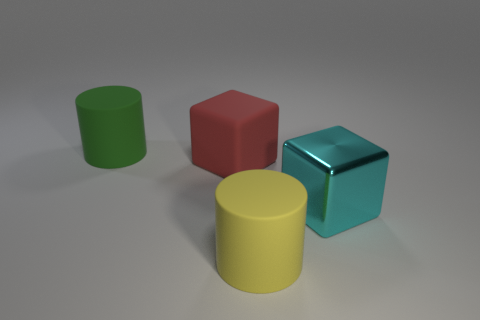Is there anything else that has the same material as the large cyan object?
Your response must be concise. No. What number of objects are blocks behind the cyan metal block or cubes behind the big metallic cube?
Offer a terse response. 1. There is a cylinder to the left of the red matte thing; is it the same size as the big cyan metal object?
Give a very brief answer. Yes. What is the size of the rubber thing that is the same shape as the shiny object?
Your answer should be compact. Large. There is a yellow cylinder that is the same size as the cyan block; what material is it?
Provide a succinct answer. Rubber. There is another thing that is the same shape as the big metal object; what material is it?
Provide a short and direct response. Rubber. What number of other objects are the same size as the cyan thing?
Make the answer very short. 3. What shape is the big red matte object?
Make the answer very short. Cube. There is a large thing that is behind the yellow matte cylinder and on the right side of the red object; what color is it?
Your answer should be compact. Cyan. What is the large green cylinder made of?
Ensure brevity in your answer.  Rubber. 